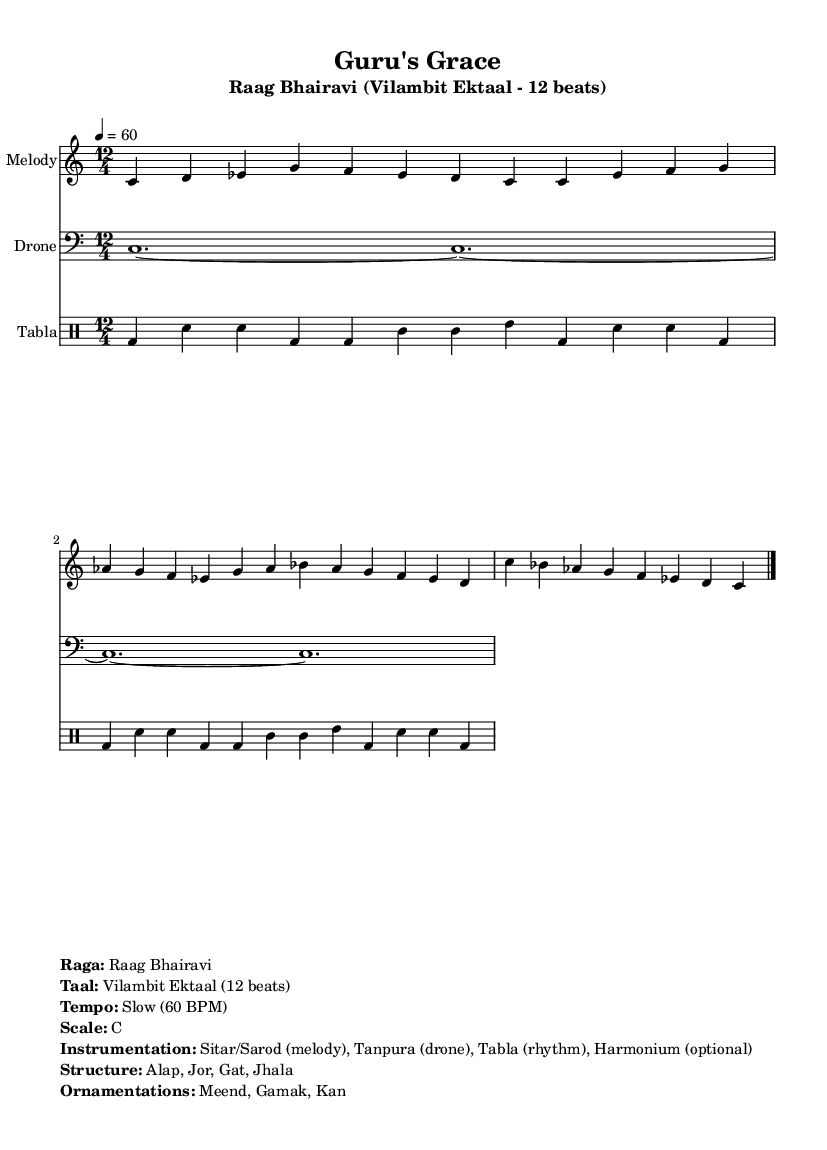What is the title of the composition? The title is indicated in the header section of the sheet music, listed prominently as "Guru's Grace".
Answer: Guru's Grace What is the key signature of this music? The key signature is derived from the global settings, which specify C major, and indicates there are no sharps or flats.
Answer: C major What is the time signature of the piece? The time signature can be found in the global settings, specified as 12/4, indicating there are 12 beats per measure.
Answer: 12/4 What is the tempo marking for this composition? The tempo marking is indicated in the global settings, which shows a tempo of 60 beats per minute.
Answer: 60 BPM What is the primary instrument used for the melody? The instrumentation section lists "Sitar/Sarod" as the primary instrument for the melody, which is typical for Indian classical music.
Answer: Sitar/Sarod Which raga is being performed? The name of the raga is explicitly stated in the markup section as "Raag Bhairavi", which is known for evoking emotions of gratitude and respect.
Answer: Raag Bhairavi What ornamentation techniques are mentioned for this raga? The ornamentations listed in the markup include "Meend, Gamak, Kan", which are traditional expressive techniques in Indian classical music.
Answer: Meend, Gamak, Kan 